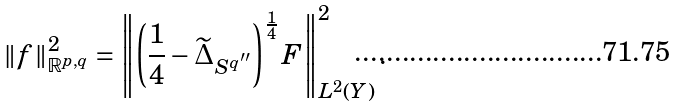Convert formula to latex. <formula><loc_0><loc_0><loc_500><loc_500>\| f \| _ { \mathbb { R } ^ { p , q } } ^ { 2 } = \left \| \left ( \frac { 1 } { 4 } - \widetilde { \Delta } _ { S ^ { q ^ { \prime \prime } } } \right ) ^ { \frac { 1 } { 4 } } F \right \| _ { L ^ { 2 } ( Y ) } ^ { 2 } .</formula> 